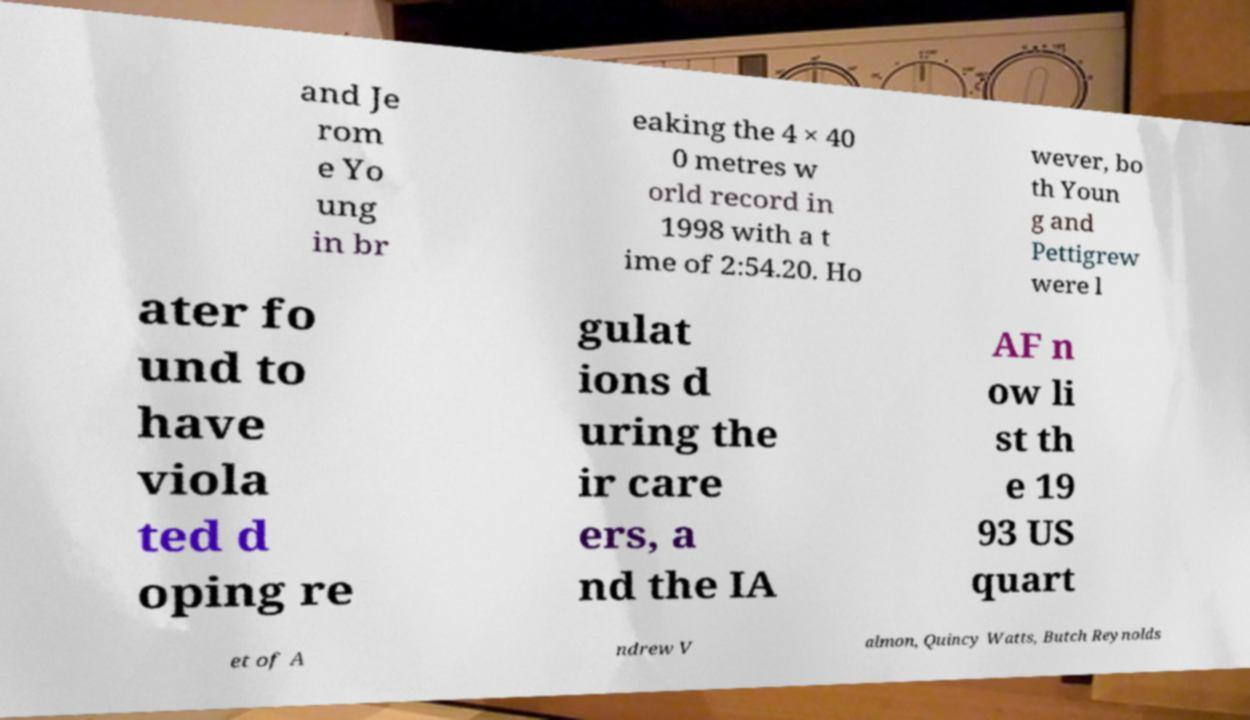Can you read and provide the text displayed in the image?This photo seems to have some interesting text. Can you extract and type it out for me? and Je rom e Yo ung in br eaking the 4 × 40 0 metres w orld record in 1998 with a t ime of 2:54.20. Ho wever, bo th Youn g and Pettigrew were l ater fo und to have viola ted d oping re gulat ions d uring the ir care ers, a nd the IA AF n ow li st th e 19 93 US quart et of A ndrew V almon, Quincy Watts, Butch Reynolds 